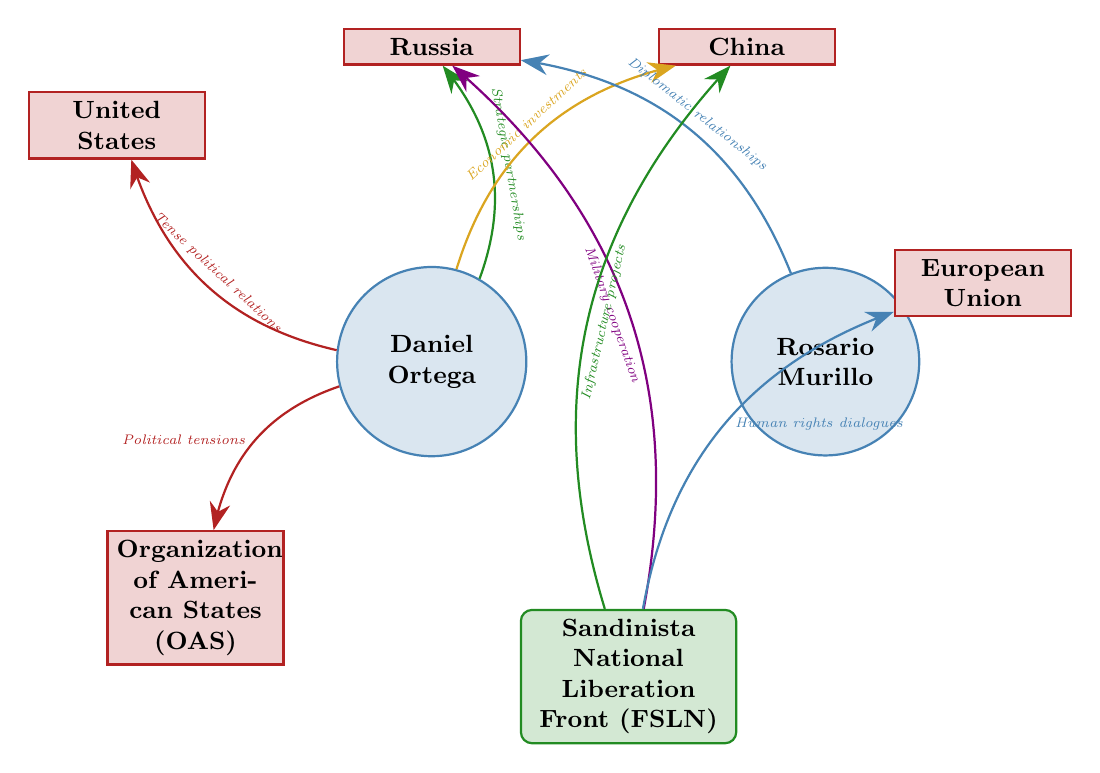What is the relationship between Daniel Ortega and the United States? The diagram indicates that the relationship between Daniel Ortega and the United States is labeled as "Tense political relations." This is the direct link shown in the diagram, clearly marked with the appropriate label.
Answer: Tense political relations How many nodes are present in the diagram? The diagram consists of eight nodes in total: Daniel Ortega, Rosario Murillo, Sandinista National Liberation Front (FSLN), United States, Russia, China, European Union, and Organization of American States (OAS). By counting each unique node in the diagram, we confirm the total.
Answer: 8 Which international entity is connected to Sandinista National Liberation Front (FSLN) for military cooperation? The diagram shows a direct link from Sandinista National Liberation Front (FSLN) to Russia with the relationship labeled as "Military cooperation." This indicates that Russia is the international entity linked to FSLN for this specific cooperation.
Answer: Russia What type of relationship does Rosario Murillo have with Russia? According to the diagram, Rosario Murillo has a relationship with Russia characterized as "Diplomatic relationships." This information is clearly illustrated in the link from Murillo to Russia.
Answer: Diplomatic relationships Which political figure has connections to both China and Russia? The diagram shows that Daniel Ortega is connected to both China (with the relationship "Economic investments") and Russia (with the relationship "Strategic partnerships"). Linking these pieces of information reveals Ortega's connections to both countries.
Answer: Daniel Ortega What is the relationship between the Sandinista National Liberation Front (FSLN) and the European Union? The link from the Sandinista National Liberation Front (FSLN) to the European Union is marked with "Human rights dialogues." This relationship is highlighted in the diagram, showing the nature of their connection.
Answer: Human rights dialogues How many relationships are illustrated in total in the diagram? The diagram illustrates a total of seven distinct relationships, each represented by a link between nodes, showcasing the connections and interactions among the political figures and international entities. By counting these links, we confirm the total number of relationships.
Answer: 7 What common element connects Daniel Ortega and the Organization of American States (OAS)? The common element that connects Daniel Ortega to the Organization of American States (OAS) is marked as "Political tensions" in the diagram. This indicates the nature of their relationship as shown in the link.
Answer: Political tensions 